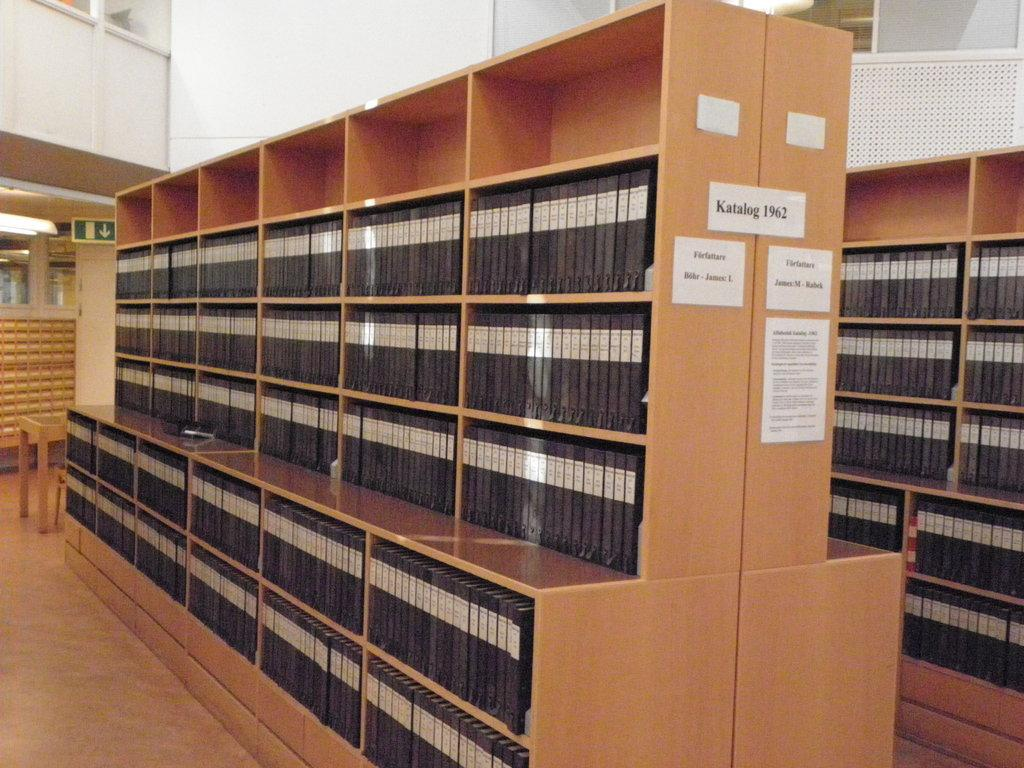<image>
Offer a succinct explanation of the picture presented. A shelf with binders has the label Katalog 1962 on its side. 